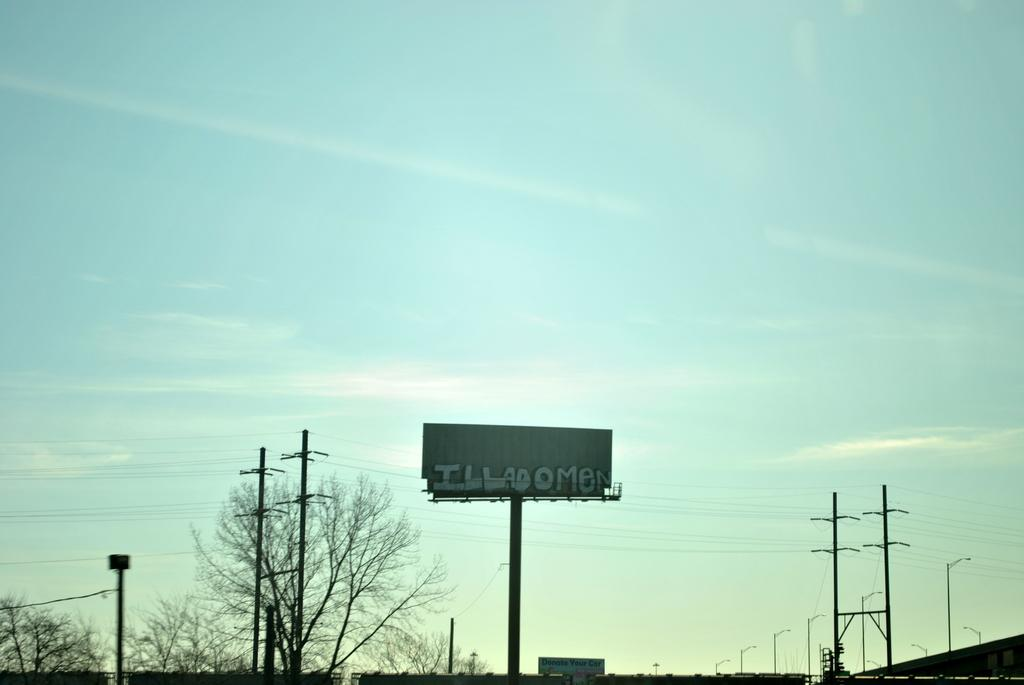<image>
Offer a succinct explanation of the picture presented. The billboard contains graffiti containing the word Illadomen. 